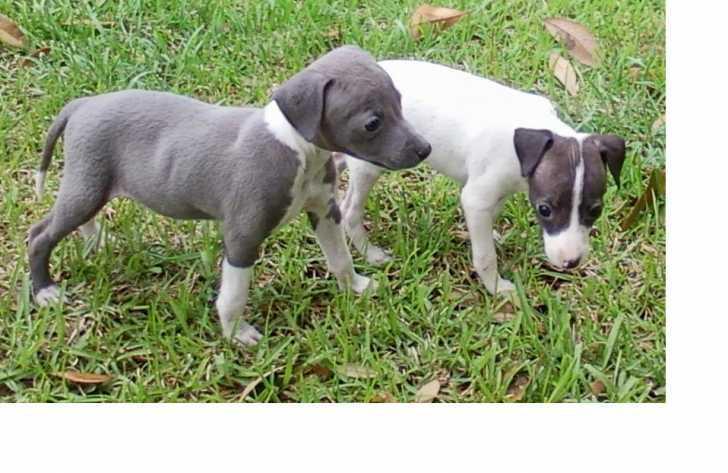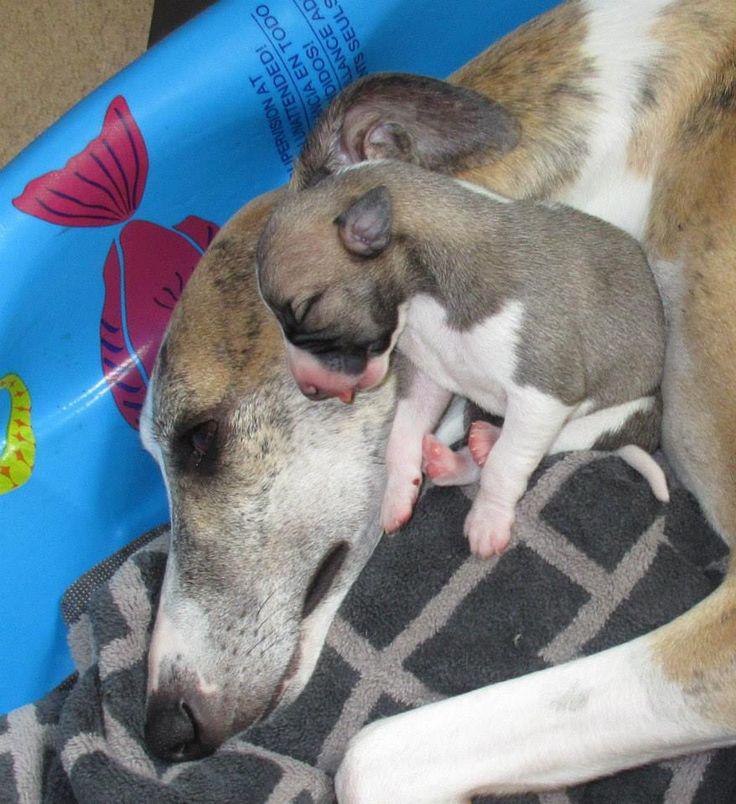The first image is the image on the left, the second image is the image on the right. Analyze the images presented: Is the assertion "There is at least one dog outside in the image on the left." valid? Answer yes or no. Yes. The first image is the image on the left, the second image is the image on the right. For the images shown, is this caption "A gray puppy with white paws is standing in front of another puppy in one image." true? Answer yes or no. Yes. 